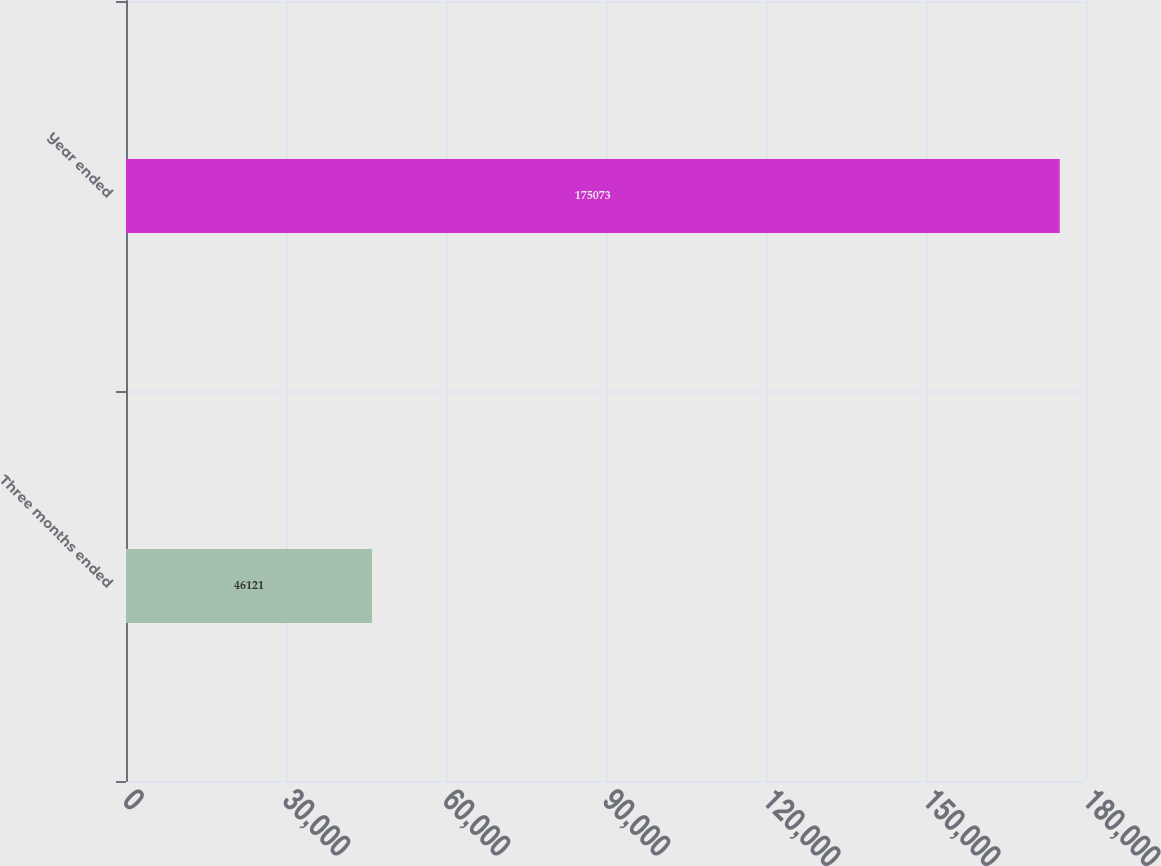Convert chart. <chart><loc_0><loc_0><loc_500><loc_500><bar_chart><fcel>Three months ended<fcel>Year ended<nl><fcel>46121<fcel>175073<nl></chart> 